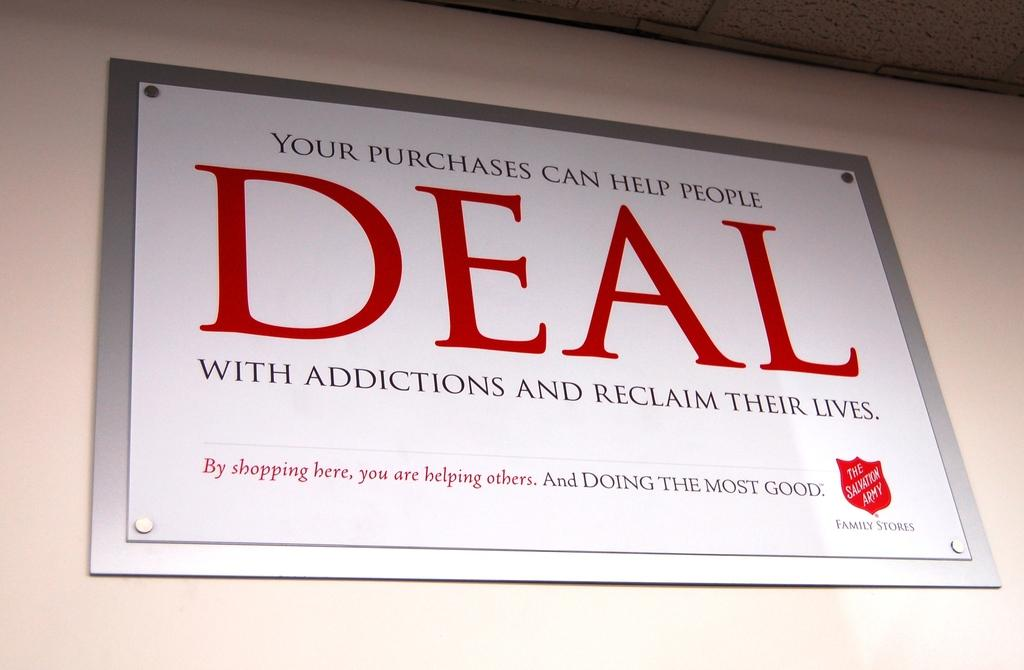<image>
Present a compact description of the photo's key features. Please help use support rehab through our DEAL program. 